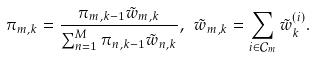Convert formula to latex. <formula><loc_0><loc_0><loc_500><loc_500>\pi _ { m , k } = \frac { \pi _ { m , k - 1 } \tilde { w } _ { m , k } } { \sum _ { n = 1 } ^ { M } \pi _ { n , k - 1 } \tilde { w } _ { n , k } } , \ \tilde { w } _ { m , k } = \sum _ { i \in \mathcal { C } _ { m } } { \tilde { w } ^ { ( i ) } _ { k } } .</formula> 